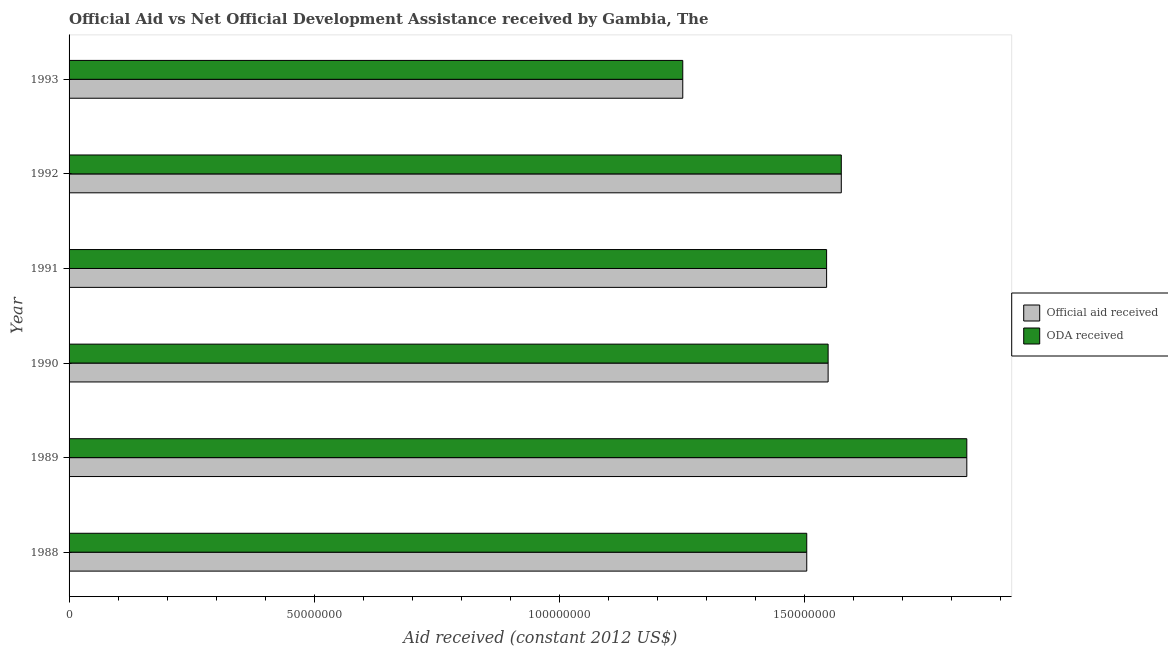How many different coloured bars are there?
Make the answer very short. 2. How many groups of bars are there?
Give a very brief answer. 6. How many bars are there on the 4th tick from the bottom?
Your answer should be compact. 2. What is the label of the 5th group of bars from the top?
Offer a very short reply. 1989. What is the official aid received in 1989?
Give a very brief answer. 1.83e+08. Across all years, what is the maximum official aid received?
Provide a succinct answer. 1.83e+08. Across all years, what is the minimum official aid received?
Your response must be concise. 1.25e+08. In which year was the official aid received maximum?
Make the answer very short. 1989. In which year was the oda received minimum?
Your answer should be very brief. 1993. What is the total oda received in the graph?
Provide a short and direct response. 9.26e+08. What is the difference between the oda received in 1988 and that in 1990?
Offer a very short reply. -4.36e+06. What is the difference between the official aid received in 1989 and the oda received in 1991?
Give a very brief answer. 2.86e+07. What is the average oda received per year?
Make the answer very short. 1.54e+08. In the year 1992, what is the difference between the official aid received and oda received?
Provide a succinct answer. 0. What is the difference between the highest and the second highest official aid received?
Your answer should be compact. 2.56e+07. What is the difference between the highest and the lowest oda received?
Offer a terse response. 5.80e+07. What does the 2nd bar from the top in 1990 represents?
Make the answer very short. Official aid received. What does the 2nd bar from the bottom in 1991 represents?
Offer a very short reply. ODA received. How many bars are there?
Make the answer very short. 12. Are all the bars in the graph horizontal?
Offer a terse response. Yes. Are the values on the major ticks of X-axis written in scientific E-notation?
Provide a short and direct response. No. Where does the legend appear in the graph?
Your answer should be very brief. Center right. What is the title of the graph?
Offer a very short reply. Official Aid vs Net Official Development Assistance received by Gambia, The . Does "Exports of goods" appear as one of the legend labels in the graph?
Offer a very short reply. No. What is the label or title of the X-axis?
Ensure brevity in your answer.  Aid received (constant 2012 US$). What is the Aid received (constant 2012 US$) of Official aid received in 1988?
Provide a succinct answer. 1.51e+08. What is the Aid received (constant 2012 US$) in ODA received in 1988?
Your answer should be very brief. 1.51e+08. What is the Aid received (constant 2012 US$) in Official aid received in 1989?
Make the answer very short. 1.83e+08. What is the Aid received (constant 2012 US$) in ODA received in 1989?
Offer a terse response. 1.83e+08. What is the Aid received (constant 2012 US$) of Official aid received in 1990?
Your response must be concise. 1.55e+08. What is the Aid received (constant 2012 US$) of ODA received in 1990?
Offer a terse response. 1.55e+08. What is the Aid received (constant 2012 US$) in Official aid received in 1991?
Make the answer very short. 1.55e+08. What is the Aid received (constant 2012 US$) in ODA received in 1991?
Provide a short and direct response. 1.55e+08. What is the Aid received (constant 2012 US$) in Official aid received in 1992?
Keep it short and to the point. 1.58e+08. What is the Aid received (constant 2012 US$) in ODA received in 1992?
Keep it short and to the point. 1.58e+08. What is the Aid received (constant 2012 US$) of Official aid received in 1993?
Give a very brief answer. 1.25e+08. What is the Aid received (constant 2012 US$) of ODA received in 1993?
Keep it short and to the point. 1.25e+08. Across all years, what is the maximum Aid received (constant 2012 US$) in Official aid received?
Keep it short and to the point. 1.83e+08. Across all years, what is the maximum Aid received (constant 2012 US$) in ODA received?
Offer a very short reply. 1.83e+08. Across all years, what is the minimum Aid received (constant 2012 US$) of Official aid received?
Provide a short and direct response. 1.25e+08. Across all years, what is the minimum Aid received (constant 2012 US$) in ODA received?
Keep it short and to the point. 1.25e+08. What is the total Aid received (constant 2012 US$) in Official aid received in the graph?
Provide a short and direct response. 9.26e+08. What is the total Aid received (constant 2012 US$) in ODA received in the graph?
Make the answer very short. 9.26e+08. What is the difference between the Aid received (constant 2012 US$) in Official aid received in 1988 and that in 1989?
Provide a succinct answer. -3.27e+07. What is the difference between the Aid received (constant 2012 US$) in ODA received in 1988 and that in 1989?
Provide a succinct answer. -3.27e+07. What is the difference between the Aid received (constant 2012 US$) of Official aid received in 1988 and that in 1990?
Provide a succinct answer. -4.36e+06. What is the difference between the Aid received (constant 2012 US$) of ODA received in 1988 and that in 1990?
Give a very brief answer. -4.36e+06. What is the difference between the Aid received (constant 2012 US$) of Official aid received in 1988 and that in 1991?
Your response must be concise. -4.05e+06. What is the difference between the Aid received (constant 2012 US$) of ODA received in 1988 and that in 1991?
Provide a succinct answer. -4.05e+06. What is the difference between the Aid received (constant 2012 US$) of Official aid received in 1988 and that in 1992?
Offer a very short reply. -7.05e+06. What is the difference between the Aid received (constant 2012 US$) of ODA received in 1988 and that in 1992?
Your answer should be very brief. -7.05e+06. What is the difference between the Aid received (constant 2012 US$) in Official aid received in 1988 and that in 1993?
Offer a very short reply. 2.53e+07. What is the difference between the Aid received (constant 2012 US$) in ODA received in 1988 and that in 1993?
Offer a very short reply. 2.53e+07. What is the difference between the Aid received (constant 2012 US$) in Official aid received in 1989 and that in 1990?
Your response must be concise. 2.83e+07. What is the difference between the Aid received (constant 2012 US$) of ODA received in 1989 and that in 1990?
Make the answer very short. 2.83e+07. What is the difference between the Aid received (constant 2012 US$) of Official aid received in 1989 and that in 1991?
Offer a terse response. 2.86e+07. What is the difference between the Aid received (constant 2012 US$) of ODA received in 1989 and that in 1991?
Make the answer very short. 2.86e+07. What is the difference between the Aid received (constant 2012 US$) of Official aid received in 1989 and that in 1992?
Offer a terse response. 2.56e+07. What is the difference between the Aid received (constant 2012 US$) of ODA received in 1989 and that in 1992?
Your answer should be very brief. 2.56e+07. What is the difference between the Aid received (constant 2012 US$) in Official aid received in 1989 and that in 1993?
Your response must be concise. 5.80e+07. What is the difference between the Aid received (constant 2012 US$) of ODA received in 1989 and that in 1993?
Your response must be concise. 5.80e+07. What is the difference between the Aid received (constant 2012 US$) in Official aid received in 1990 and that in 1991?
Ensure brevity in your answer.  3.10e+05. What is the difference between the Aid received (constant 2012 US$) in Official aid received in 1990 and that in 1992?
Provide a short and direct response. -2.69e+06. What is the difference between the Aid received (constant 2012 US$) in ODA received in 1990 and that in 1992?
Ensure brevity in your answer.  -2.69e+06. What is the difference between the Aid received (constant 2012 US$) in Official aid received in 1990 and that in 1993?
Your answer should be compact. 2.97e+07. What is the difference between the Aid received (constant 2012 US$) of ODA received in 1990 and that in 1993?
Offer a terse response. 2.97e+07. What is the difference between the Aid received (constant 2012 US$) in Official aid received in 1991 and that in 1993?
Your answer should be compact. 2.94e+07. What is the difference between the Aid received (constant 2012 US$) of ODA received in 1991 and that in 1993?
Ensure brevity in your answer.  2.94e+07. What is the difference between the Aid received (constant 2012 US$) in Official aid received in 1992 and that in 1993?
Make the answer very short. 3.24e+07. What is the difference between the Aid received (constant 2012 US$) in ODA received in 1992 and that in 1993?
Ensure brevity in your answer.  3.24e+07. What is the difference between the Aid received (constant 2012 US$) in Official aid received in 1988 and the Aid received (constant 2012 US$) in ODA received in 1989?
Give a very brief answer. -3.27e+07. What is the difference between the Aid received (constant 2012 US$) of Official aid received in 1988 and the Aid received (constant 2012 US$) of ODA received in 1990?
Provide a short and direct response. -4.36e+06. What is the difference between the Aid received (constant 2012 US$) of Official aid received in 1988 and the Aid received (constant 2012 US$) of ODA received in 1991?
Ensure brevity in your answer.  -4.05e+06. What is the difference between the Aid received (constant 2012 US$) in Official aid received in 1988 and the Aid received (constant 2012 US$) in ODA received in 1992?
Your answer should be compact. -7.05e+06. What is the difference between the Aid received (constant 2012 US$) of Official aid received in 1988 and the Aid received (constant 2012 US$) of ODA received in 1993?
Ensure brevity in your answer.  2.53e+07. What is the difference between the Aid received (constant 2012 US$) of Official aid received in 1989 and the Aid received (constant 2012 US$) of ODA received in 1990?
Provide a succinct answer. 2.83e+07. What is the difference between the Aid received (constant 2012 US$) in Official aid received in 1989 and the Aid received (constant 2012 US$) in ODA received in 1991?
Your response must be concise. 2.86e+07. What is the difference between the Aid received (constant 2012 US$) in Official aid received in 1989 and the Aid received (constant 2012 US$) in ODA received in 1992?
Your response must be concise. 2.56e+07. What is the difference between the Aid received (constant 2012 US$) in Official aid received in 1989 and the Aid received (constant 2012 US$) in ODA received in 1993?
Your answer should be compact. 5.80e+07. What is the difference between the Aid received (constant 2012 US$) of Official aid received in 1990 and the Aid received (constant 2012 US$) of ODA received in 1991?
Ensure brevity in your answer.  3.10e+05. What is the difference between the Aid received (constant 2012 US$) of Official aid received in 1990 and the Aid received (constant 2012 US$) of ODA received in 1992?
Make the answer very short. -2.69e+06. What is the difference between the Aid received (constant 2012 US$) of Official aid received in 1990 and the Aid received (constant 2012 US$) of ODA received in 1993?
Offer a terse response. 2.97e+07. What is the difference between the Aid received (constant 2012 US$) of Official aid received in 1991 and the Aid received (constant 2012 US$) of ODA received in 1993?
Keep it short and to the point. 2.94e+07. What is the difference between the Aid received (constant 2012 US$) in Official aid received in 1992 and the Aid received (constant 2012 US$) in ODA received in 1993?
Offer a very short reply. 3.24e+07. What is the average Aid received (constant 2012 US$) in Official aid received per year?
Your answer should be compact. 1.54e+08. What is the average Aid received (constant 2012 US$) of ODA received per year?
Your answer should be very brief. 1.54e+08. In the year 1988, what is the difference between the Aid received (constant 2012 US$) of Official aid received and Aid received (constant 2012 US$) of ODA received?
Keep it short and to the point. 0. In the year 1990, what is the difference between the Aid received (constant 2012 US$) in Official aid received and Aid received (constant 2012 US$) in ODA received?
Your response must be concise. 0. In the year 1992, what is the difference between the Aid received (constant 2012 US$) in Official aid received and Aid received (constant 2012 US$) in ODA received?
Offer a very short reply. 0. What is the ratio of the Aid received (constant 2012 US$) of Official aid received in 1988 to that in 1989?
Keep it short and to the point. 0.82. What is the ratio of the Aid received (constant 2012 US$) in ODA received in 1988 to that in 1989?
Your answer should be compact. 0.82. What is the ratio of the Aid received (constant 2012 US$) of Official aid received in 1988 to that in 1990?
Make the answer very short. 0.97. What is the ratio of the Aid received (constant 2012 US$) in ODA received in 1988 to that in 1990?
Your answer should be compact. 0.97. What is the ratio of the Aid received (constant 2012 US$) of Official aid received in 1988 to that in 1991?
Ensure brevity in your answer.  0.97. What is the ratio of the Aid received (constant 2012 US$) in ODA received in 1988 to that in 1991?
Give a very brief answer. 0.97. What is the ratio of the Aid received (constant 2012 US$) of Official aid received in 1988 to that in 1992?
Offer a very short reply. 0.96. What is the ratio of the Aid received (constant 2012 US$) in ODA received in 1988 to that in 1992?
Provide a succinct answer. 0.96. What is the ratio of the Aid received (constant 2012 US$) in Official aid received in 1988 to that in 1993?
Ensure brevity in your answer.  1.2. What is the ratio of the Aid received (constant 2012 US$) in ODA received in 1988 to that in 1993?
Ensure brevity in your answer.  1.2. What is the ratio of the Aid received (constant 2012 US$) in Official aid received in 1989 to that in 1990?
Give a very brief answer. 1.18. What is the ratio of the Aid received (constant 2012 US$) in ODA received in 1989 to that in 1990?
Your response must be concise. 1.18. What is the ratio of the Aid received (constant 2012 US$) of Official aid received in 1989 to that in 1991?
Keep it short and to the point. 1.19. What is the ratio of the Aid received (constant 2012 US$) in ODA received in 1989 to that in 1991?
Offer a very short reply. 1.19. What is the ratio of the Aid received (constant 2012 US$) of Official aid received in 1989 to that in 1992?
Make the answer very short. 1.16. What is the ratio of the Aid received (constant 2012 US$) in ODA received in 1989 to that in 1992?
Keep it short and to the point. 1.16. What is the ratio of the Aid received (constant 2012 US$) in Official aid received in 1989 to that in 1993?
Provide a succinct answer. 1.46. What is the ratio of the Aid received (constant 2012 US$) of ODA received in 1989 to that in 1993?
Your answer should be compact. 1.46. What is the ratio of the Aid received (constant 2012 US$) in Official aid received in 1990 to that in 1991?
Make the answer very short. 1. What is the ratio of the Aid received (constant 2012 US$) of Official aid received in 1990 to that in 1992?
Your response must be concise. 0.98. What is the ratio of the Aid received (constant 2012 US$) in ODA received in 1990 to that in 1992?
Your response must be concise. 0.98. What is the ratio of the Aid received (constant 2012 US$) of Official aid received in 1990 to that in 1993?
Give a very brief answer. 1.24. What is the ratio of the Aid received (constant 2012 US$) in ODA received in 1990 to that in 1993?
Offer a very short reply. 1.24. What is the ratio of the Aid received (constant 2012 US$) in Official aid received in 1991 to that in 1992?
Offer a very short reply. 0.98. What is the ratio of the Aid received (constant 2012 US$) of ODA received in 1991 to that in 1992?
Provide a succinct answer. 0.98. What is the ratio of the Aid received (constant 2012 US$) of Official aid received in 1991 to that in 1993?
Your answer should be very brief. 1.23. What is the ratio of the Aid received (constant 2012 US$) in ODA received in 1991 to that in 1993?
Provide a succinct answer. 1.23. What is the ratio of the Aid received (constant 2012 US$) in Official aid received in 1992 to that in 1993?
Your response must be concise. 1.26. What is the ratio of the Aid received (constant 2012 US$) in ODA received in 1992 to that in 1993?
Provide a succinct answer. 1.26. What is the difference between the highest and the second highest Aid received (constant 2012 US$) of Official aid received?
Offer a very short reply. 2.56e+07. What is the difference between the highest and the second highest Aid received (constant 2012 US$) in ODA received?
Offer a very short reply. 2.56e+07. What is the difference between the highest and the lowest Aid received (constant 2012 US$) in Official aid received?
Provide a short and direct response. 5.80e+07. What is the difference between the highest and the lowest Aid received (constant 2012 US$) in ODA received?
Ensure brevity in your answer.  5.80e+07. 